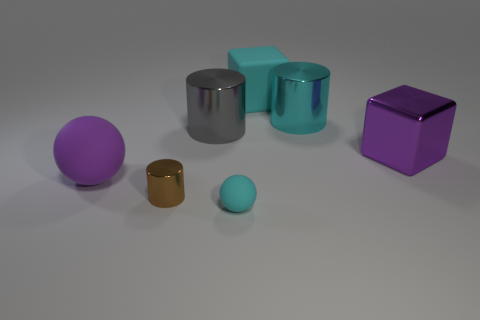There is a large purple object that is behind the large purple rubber thing in front of the purple object right of the big rubber ball; what shape is it?
Keep it short and to the point. Cube. There is a purple block that is made of the same material as the large cyan cylinder; what size is it?
Provide a short and direct response. Large. What size is the cyan shiny thing that is the same shape as the gray thing?
Give a very brief answer. Large. Are there any shiny objects?
Make the answer very short. Yes. What number of things are purple objects that are to the left of the big cyan cylinder or brown metallic cylinders?
Keep it short and to the point. 2. There is a cyan object that is the same size as the brown cylinder; what material is it?
Provide a succinct answer. Rubber. There is a big rubber thing that is in front of the rubber thing behind the big purple metallic object; what color is it?
Offer a terse response. Purple. There is a large purple rubber sphere; what number of brown metallic things are behind it?
Your response must be concise. 0. The matte block has what color?
Your answer should be compact. Cyan. How many big things are gray shiny cylinders or rubber cubes?
Give a very brief answer. 2. 